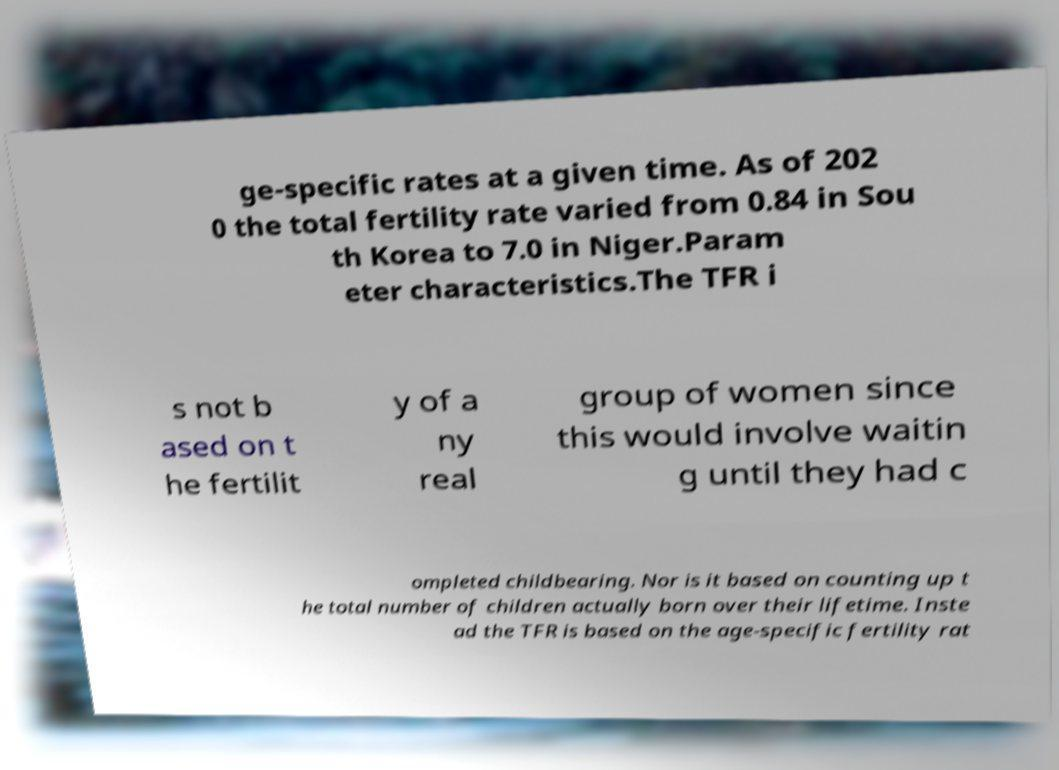There's text embedded in this image that I need extracted. Can you transcribe it verbatim? ge-specific rates at a given time. As of 202 0 the total fertility rate varied from 0.84 in Sou th Korea to 7.0 in Niger.Param eter characteristics.The TFR i s not b ased on t he fertilit y of a ny real group of women since this would involve waitin g until they had c ompleted childbearing. Nor is it based on counting up t he total number of children actually born over their lifetime. Inste ad the TFR is based on the age-specific fertility rat 